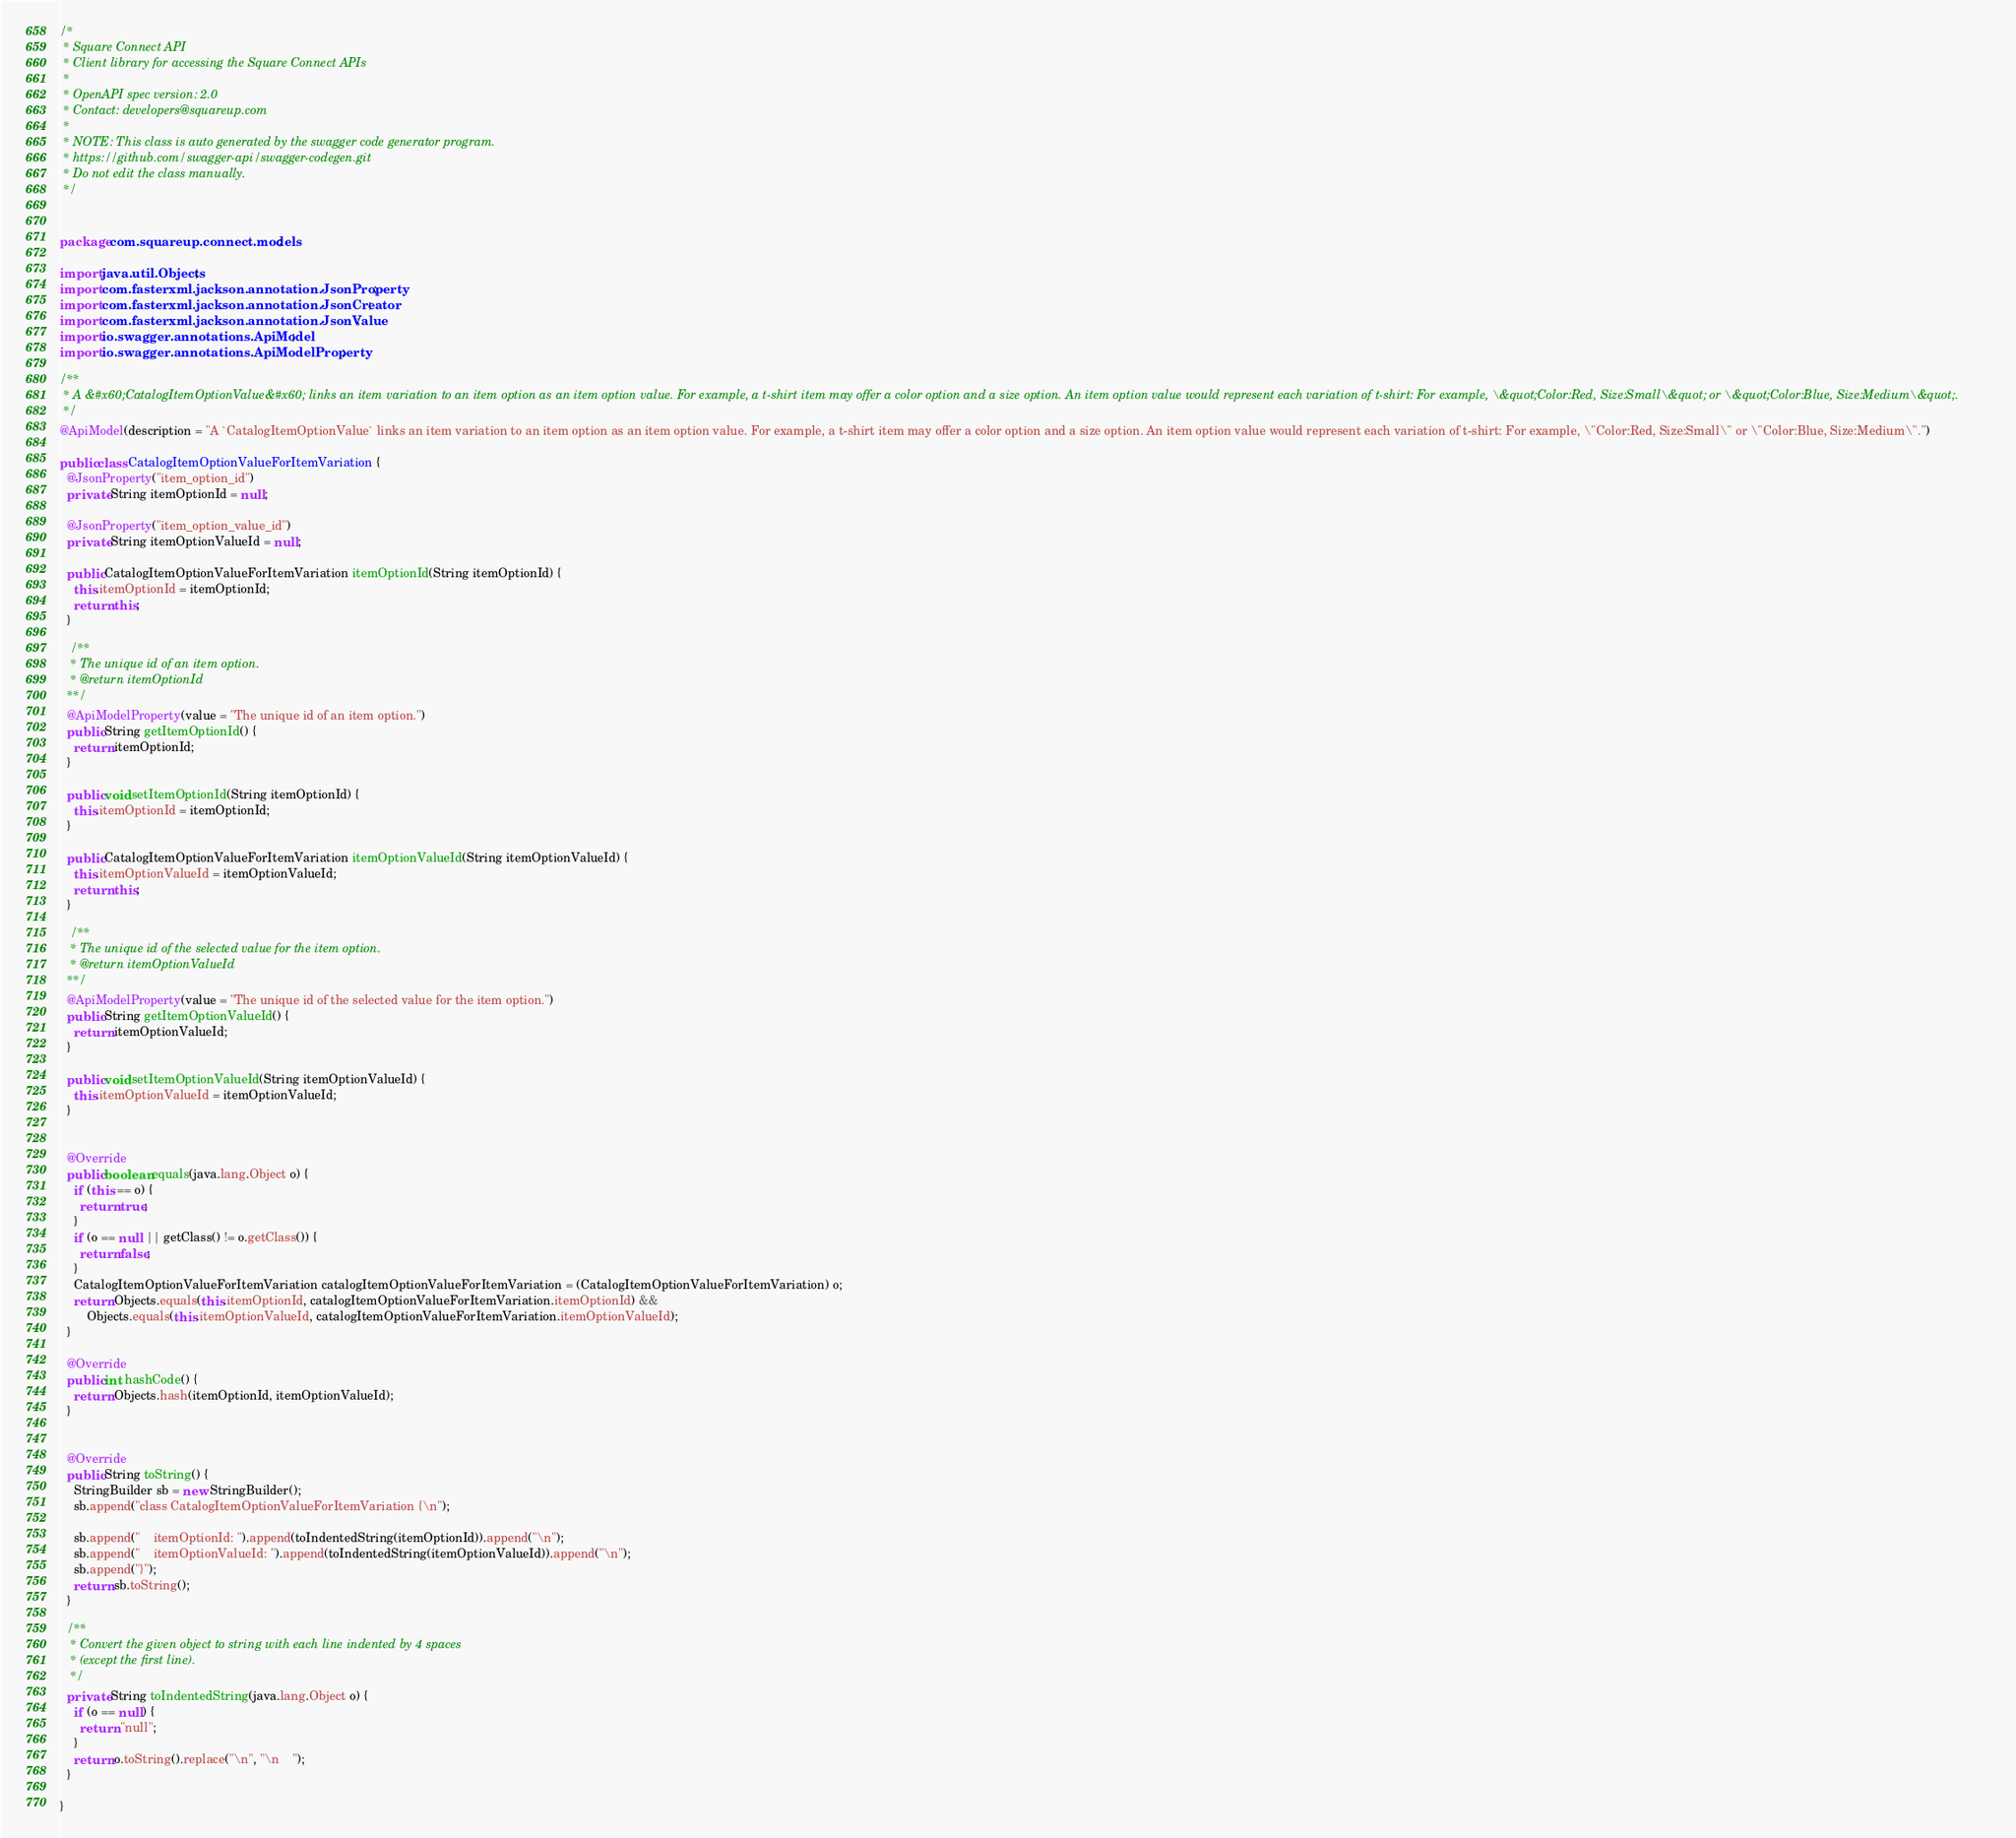<code> <loc_0><loc_0><loc_500><loc_500><_Java_>/*
 * Square Connect API
 * Client library for accessing the Square Connect APIs
 *
 * OpenAPI spec version: 2.0
 * Contact: developers@squareup.com
 *
 * NOTE: This class is auto generated by the swagger code generator program.
 * https://github.com/swagger-api/swagger-codegen.git
 * Do not edit the class manually.
 */


package com.squareup.connect.models;

import java.util.Objects;
import com.fasterxml.jackson.annotation.JsonProperty;
import com.fasterxml.jackson.annotation.JsonCreator;
import com.fasterxml.jackson.annotation.JsonValue;
import io.swagger.annotations.ApiModel;
import io.swagger.annotations.ApiModelProperty;

/**
 * A &#x60;CatalogItemOptionValue&#x60; links an item variation to an item option as an item option value. For example, a t-shirt item may offer a color option and a size option. An item option value would represent each variation of t-shirt: For example, \&quot;Color:Red, Size:Small\&quot; or \&quot;Color:Blue, Size:Medium\&quot;.
 */
@ApiModel(description = "A `CatalogItemOptionValue` links an item variation to an item option as an item option value. For example, a t-shirt item may offer a color option and a size option. An item option value would represent each variation of t-shirt: For example, \"Color:Red, Size:Small\" or \"Color:Blue, Size:Medium\".")

public class CatalogItemOptionValueForItemVariation {
  @JsonProperty("item_option_id")
  private String itemOptionId = null;

  @JsonProperty("item_option_value_id")
  private String itemOptionValueId = null;

  public CatalogItemOptionValueForItemVariation itemOptionId(String itemOptionId) {
    this.itemOptionId = itemOptionId;
    return this;
  }

   /**
   * The unique id of an item option.
   * @return itemOptionId
  **/
  @ApiModelProperty(value = "The unique id of an item option.")
  public String getItemOptionId() {
    return itemOptionId;
  }

  public void setItemOptionId(String itemOptionId) {
    this.itemOptionId = itemOptionId;
  }

  public CatalogItemOptionValueForItemVariation itemOptionValueId(String itemOptionValueId) {
    this.itemOptionValueId = itemOptionValueId;
    return this;
  }

   /**
   * The unique id of the selected value for the item option.
   * @return itemOptionValueId
  **/
  @ApiModelProperty(value = "The unique id of the selected value for the item option.")
  public String getItemOptionValueId() {
    return itemOptionValueId;
  }

  public void setItemOptionValueId(String itemOptionValueId) {
    this.itemOptionValueId = itemOptionValueId;
  }


  @Override
  public boolean equals(java.lang.Object o) {
    if (this == o) {
      return true;
    }
    if (o == null || getClass() != o.getClass()) {
      return false;
    }
    CatalogItemOptionValueForItemVariation catalogItemOptionValueForItemVariation = (CatalogItemOptionValueForItemVariation) o;
    return Objects.equals(this.itemOptionId, catalogItemOptionValueForItemVariation.itemOptionId) &&
        Objects.equals(this.itemOptionValueId, catalogItemOptionValueForItemVariation.itemOptionValueId);
  }

  @Override
  public int hashCode() {
    return Objects.hash(itemOptionId, itemOptionValueId);
  }


  @Override
  public String toString() {
    StringBuilder sb = new StringBuilder();
    sb.append("class CatalogItemOptionValueForItemVariation {\n");
    
    sb.append("    itemOptionId: ").append(toIndentedString(itemOptionId)).append("\n");
    sb.append("    itemOptionValueId: ").append(toIndentedString(itemOptionValueId)).append("\n");
    sb.append("}");
    return sb.toString();
  }

  /**
   * Convert the given object to string with each line indented by 4 spaces
   * (except the first line).
   */
  private String toIndentedString(java.lang.Object o) {
    if (o == null) {
      return "null";
    }
    return o.toString().replace("\n", "\n    ");
  }
  
}

</code> 